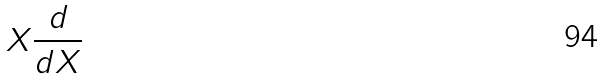Convert formula to latex. <formula><loc_0><loc_0><loc_500><loc_500>X \frac { d } { d X }</formula> 